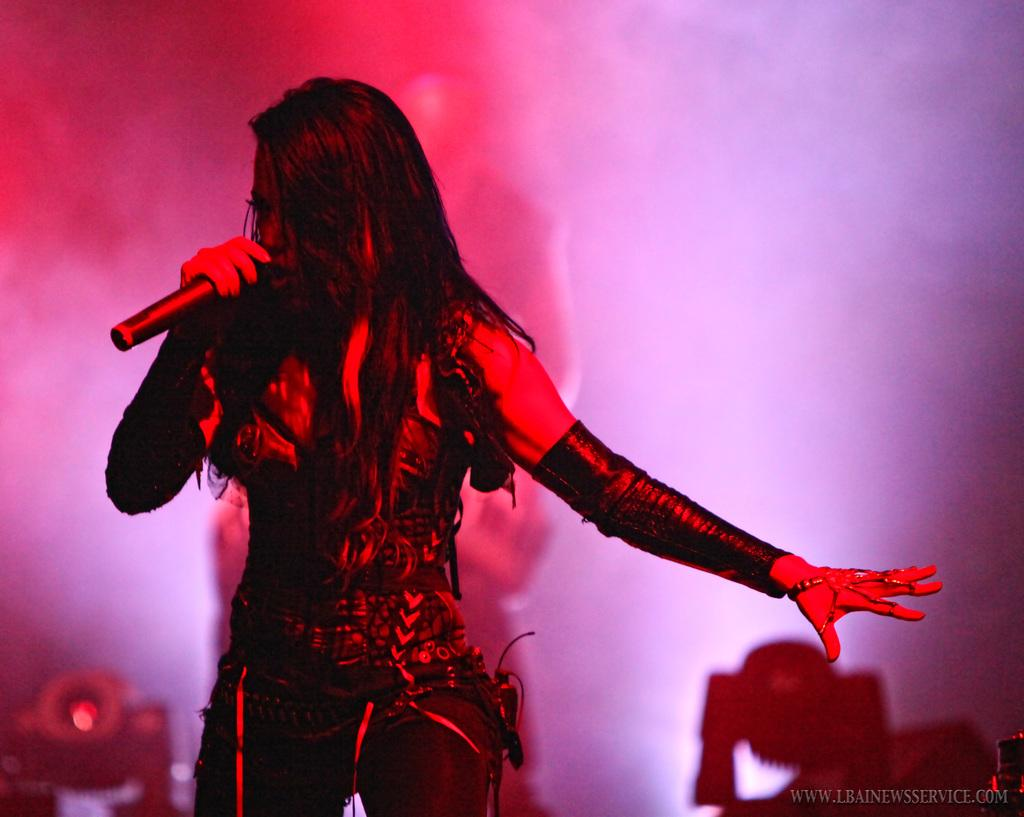What is the lady in the image doing? The lady is standing and holding a mic in the image. What can be seen in the background of the image? There are lights and a person visible in the background of the image. What type of apple is being discussed by the lady in the image? There is no apple or discussion about an apple present in the image. What type of flag is visible in the image? There is no flag visible in the image. 